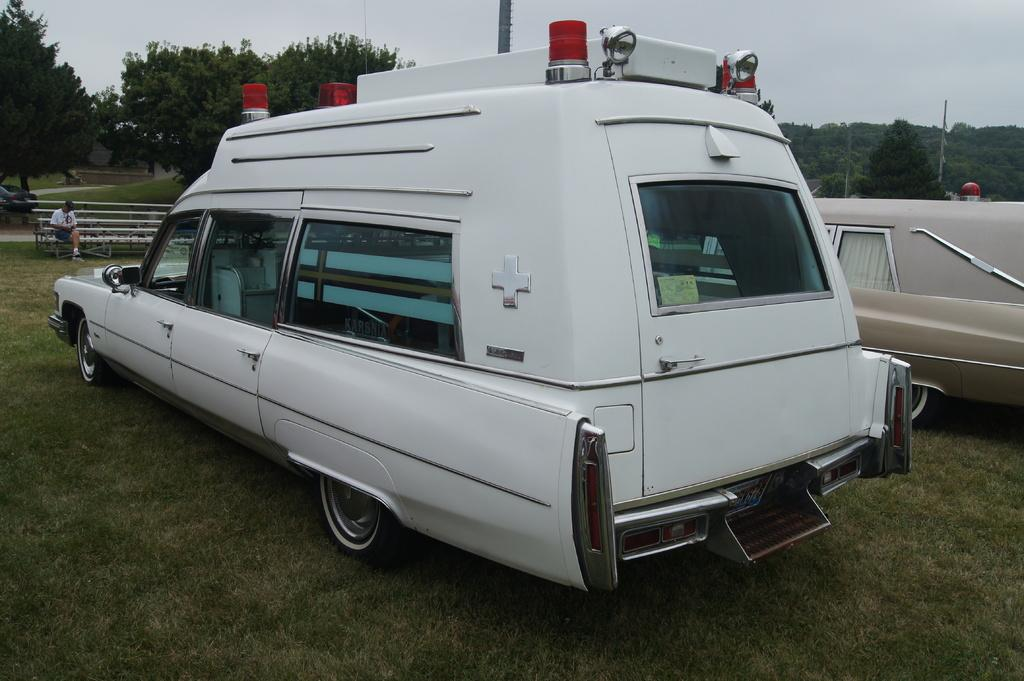What vehicles are present in the image? There are two ambulances in the image. What is the status of the ambulances in the image? The ambulances are parked. What can be seen in front of the ambulances? There is a person sitting on a bench in front of the ambulances. What is visible behind the person? There are trees visible behind the person. What color is the crayon that the person is using to draw on the ambulance? There is no crayon present in the image, and the person is not drawing on the ambulance. Who is the friend that the person is talking to while sitting on the bench? There is no friend visible in the image, and the person is not talking to anyone. 